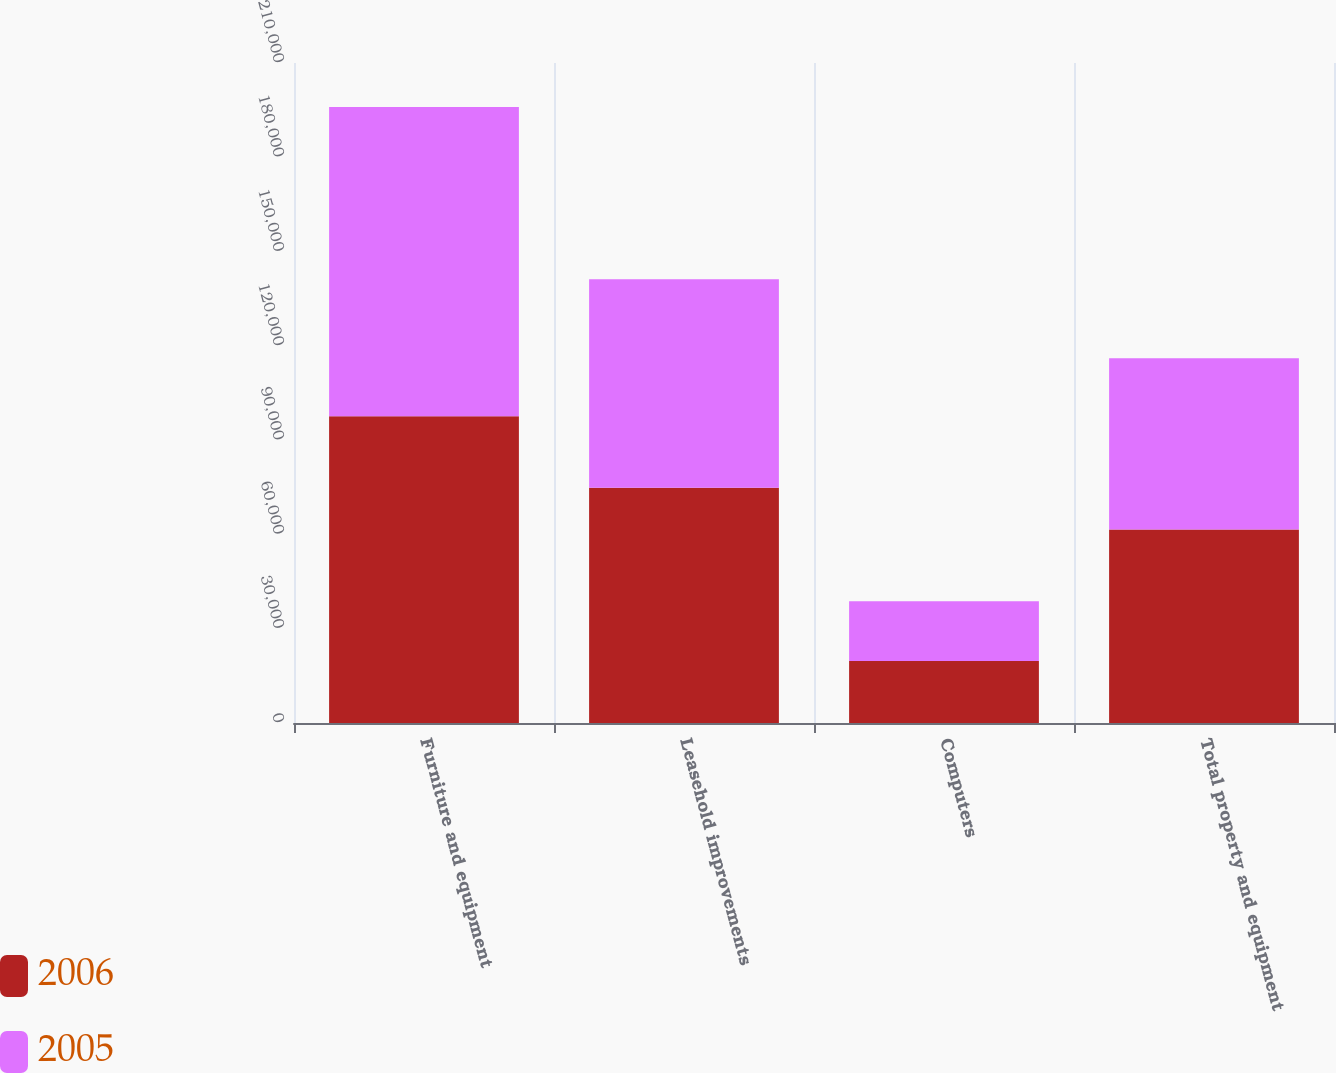<chart> <loc_0><loc_0><loc_500><loc_500><stacked_bar_chart><ecel><fcel>Furniture and equipment<fcel>Leasehold improvements<fcel>Computers<fcel>Total property and equipment<nl><fcel>2006<fcel>97638<fcel>74875<fcel>19733<fcel>61535<nl><fcel>2005<fcel>98387<fcel>66318<fcel>18971<fcel>54533<nl></chart> 